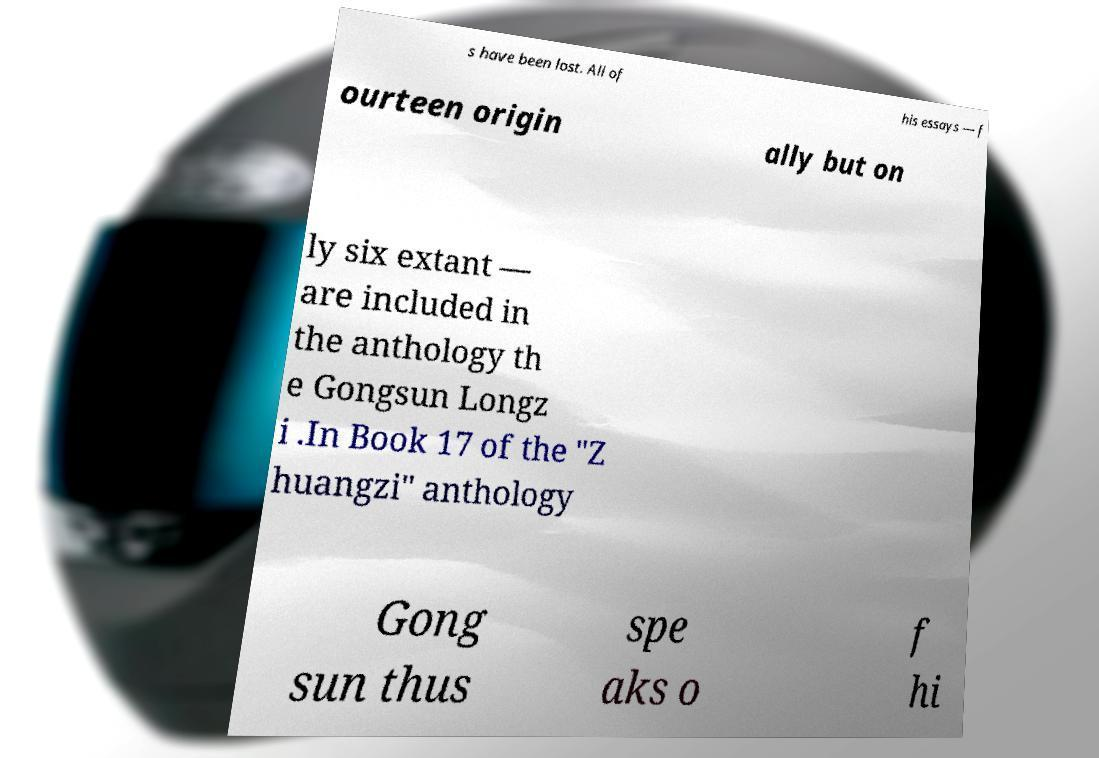Can you read and provide the text displayed in the image?This photo seems to have some interesting text. Can you extract and type it out for me? s have been lost. All of his essays — f ourteen origin ally but on ly six extant — are included in the anthology th e Gongsun Longz i .In Book 17 of the "Z huangzi" anthology Gong sun thus spe aks o f hi 